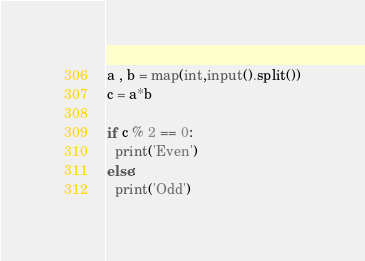<code> <loc_0><loc_0><loc_500><loc_500><_Python_>
a , b = map(int,input().split())
c = a*b

if c % 2 == 0:
  print('Even')
else:
  print('Odd')</code> 